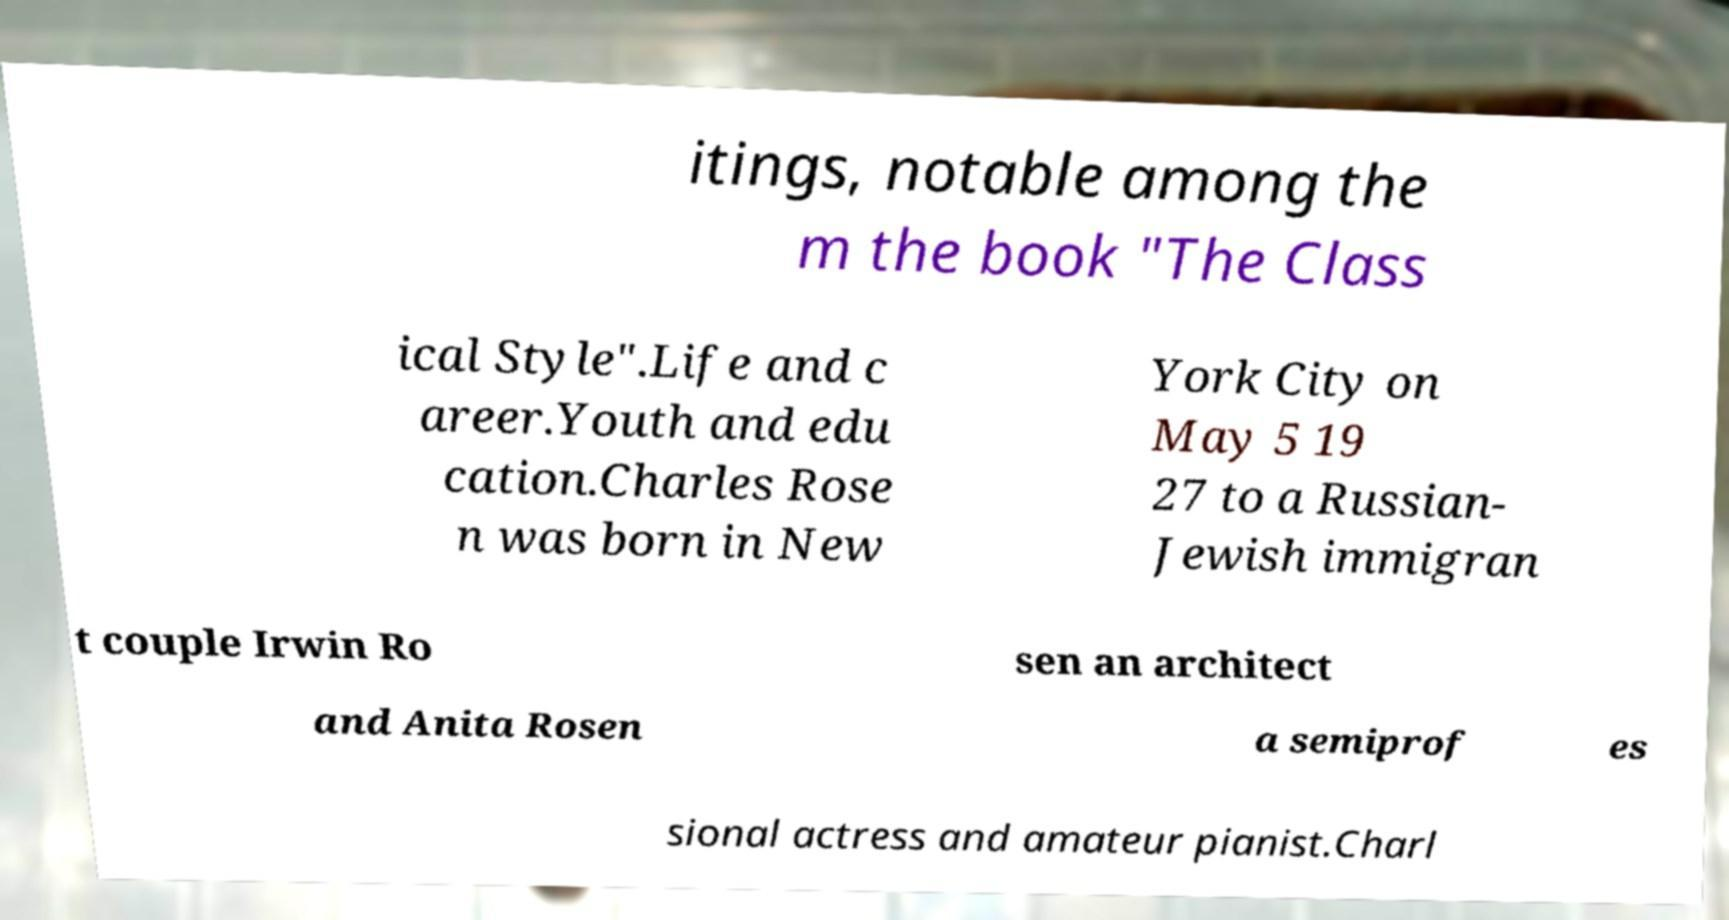What messages or text are displayed in this image? I need them in a readable, typed format. itings, notable among the m the book "The Class ical Style".Life and c areer.Youth and edu cation.Charles Rose n was born in New York City on May 5 19 27 to a Russian- Jewish immigran t couple Irwin Ro sen an architect and Anita Rosen a semiprof es sional actress and amateur pianist.Charl 